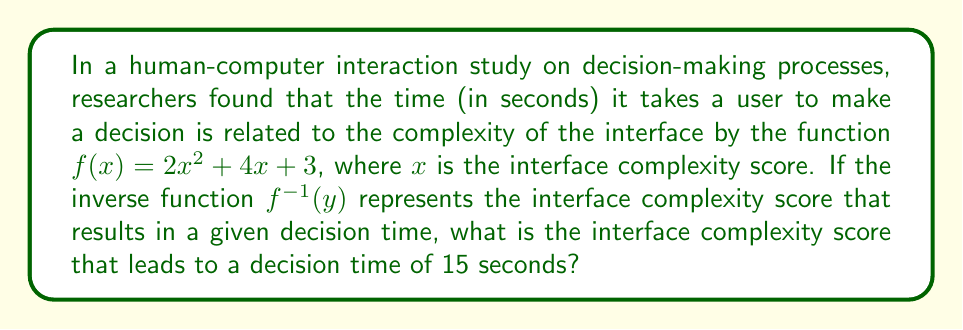Teach me how to tackle this problem. To solve this problem, we need to find the inverse function $f^{-1}(y)$ and then evaluate it at $y = 15$. Here's the step-by-step process:

1) Start with the original function: $f(x) = 2x^2 + 4x + 3$

2) To find the inverse, replace $f(x)$ with $y$:
   $y = 2x^2 + 4x + 3$

3) Swap $x$ and $y$:
   $x = 2y^2 + 4y + 3$

4) Solve for $y$:
   $x - 3 = 2y^2 + 4y$
   $\frac{x - 3}{2} = y^2 + 2y$

5) Complete the square:
   $\frac{x - 3}{2} = (y + 1)^2 - 1$
   $\frac{x - 1}{2} = (y + 1)^2$

6) Take the square root of both sides:
   $\pm\sqrt{\frac{x - 1}{2}} = y + 1$

7) Solve for $y$:
   $y = -1 \pm \sqrt{\frac{x - 1}{2}}$

8) Since we're dealing with positive complexity scores, we'll use the positive root:
   $f^{-1}(x) = -1 + \sqrt{\frac{x - 1}{2}}$

9) Now, evaluate $f^{-1}(15)$:
   $f^{-1}(15) = -1 + \sqrt{\frac{15 - 1}{2}} = -1 + \sqrt{7} \approx 1.65$

Therefore, the interface complexity score that leads to a decision time of 15 seconds is approximately 1.65.
Answer: $-1 + \sqrt{7} \approx 1.65$ 